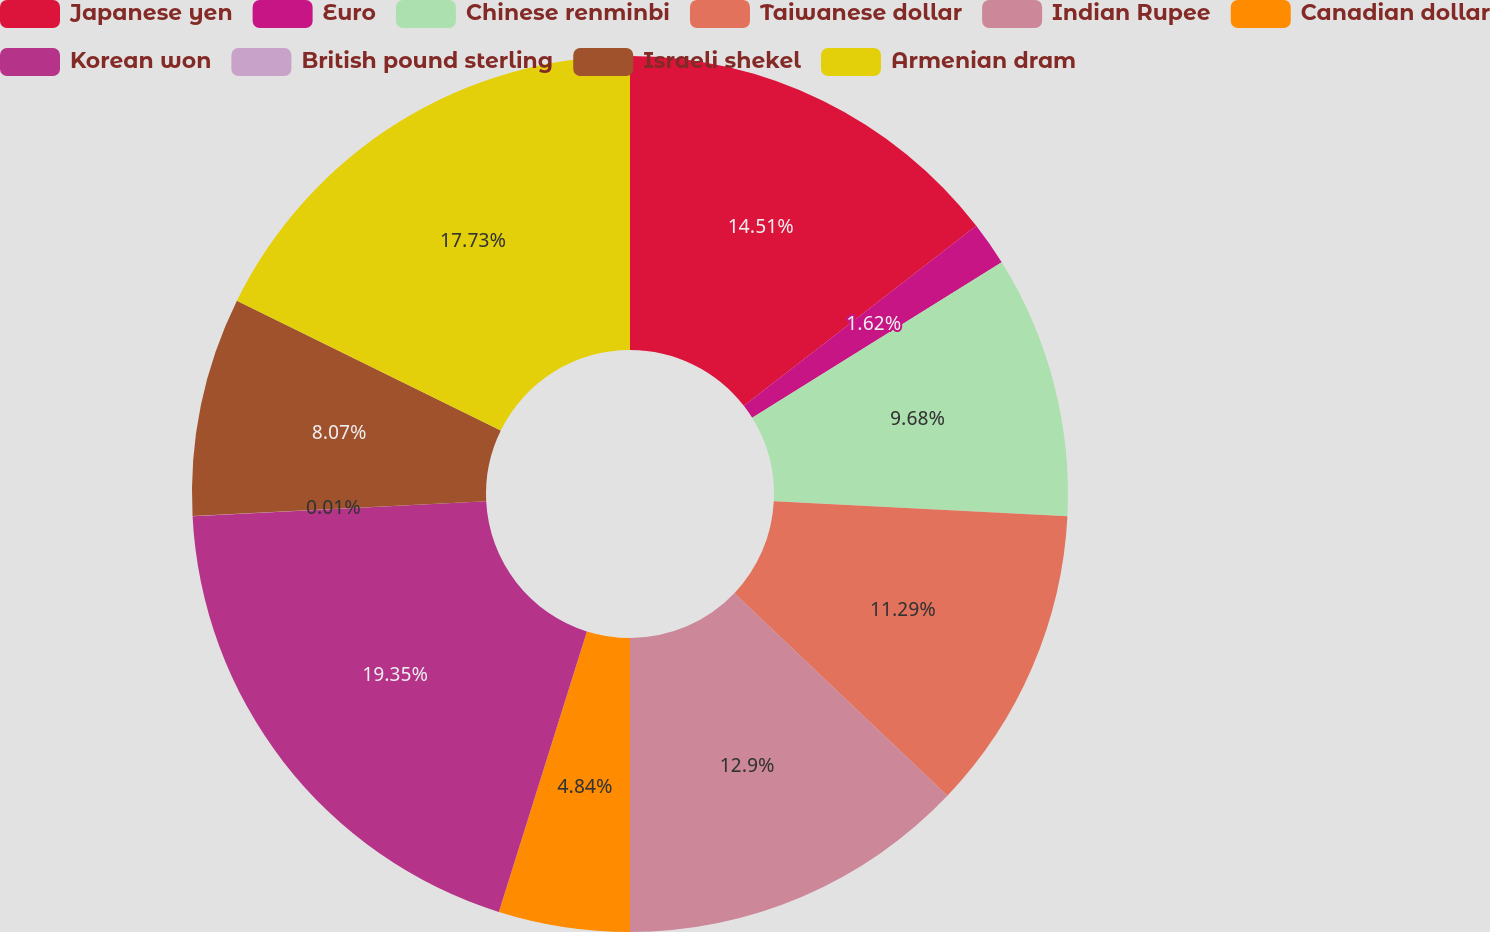Convert chart. <chart><loc_0><loc_0><loc_500><loc_500><pie_chart><fcel>Japanese yen<fcel>Euro<fcel>Chinese renminbi<fcel>Taiwanese dollar<fcel>Indian Rupee<fcel>Canadian dollar<fcel>Korean won<fcel>British pound sterling<fcel>Israeli shekel<fcel>Armenian dram<nl><fcel>14.51%<fcel>1.62%<fcel>9.68%<fcel>11.29%<fcel>12.9%<fcel>4.84%<fcel>19.35%<fcel>0.01%<fcel>8.07%<fcel>17.73%<nl></chart> 